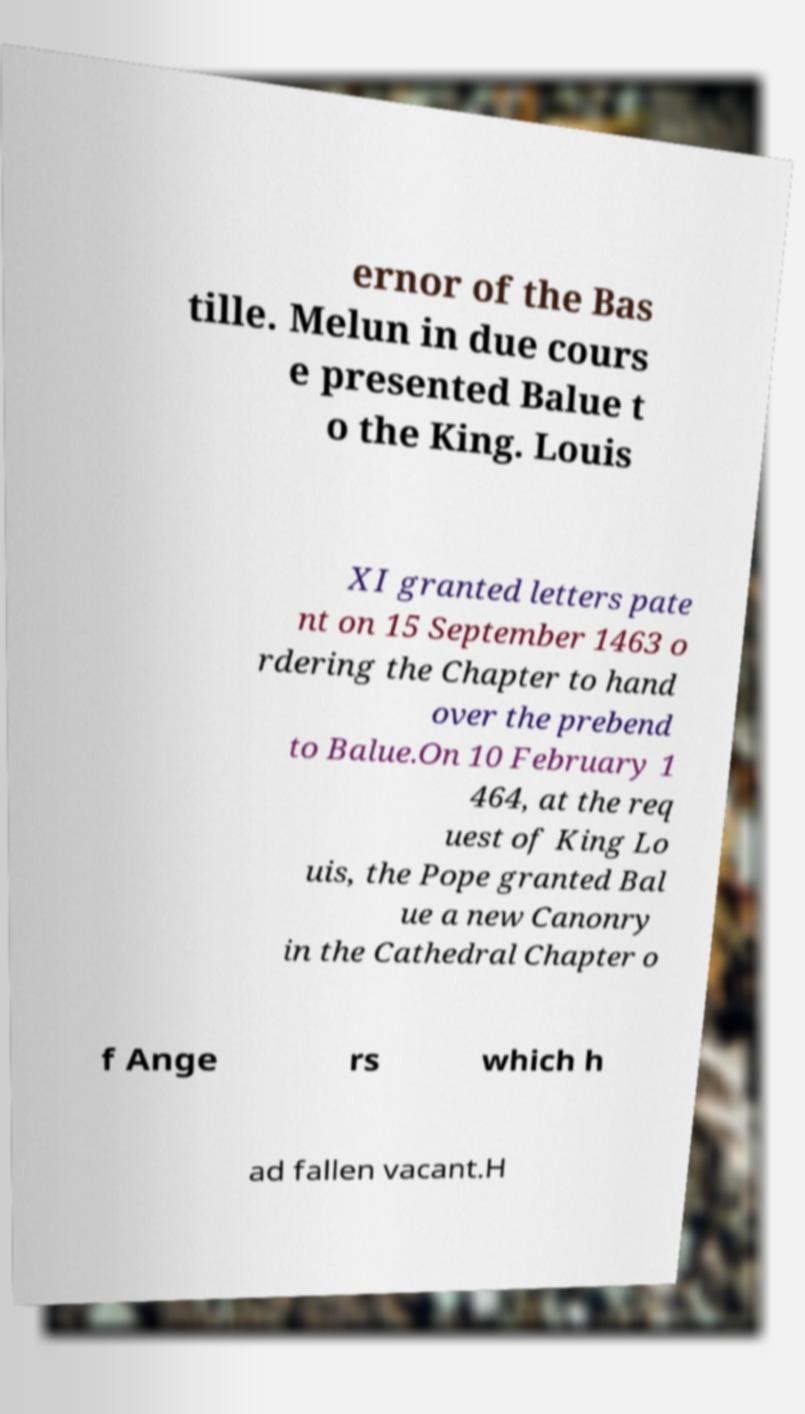For documentation purposes, I need the text within this image transcribed. Could you provide that? ernor of the Bas tille. Melun in due cours e presented Balue t o the King. Louis XI granted letters pate nt on 15 September 1463 o rdering the Chapter to hand over the prebend to Balue.On 10 February 1 464, at the req uest of King Lo uis, the Pope granted Bal ue a new Canonry in the Cathedral Chapter o f Ange rs which h ad fallen vacant.H 